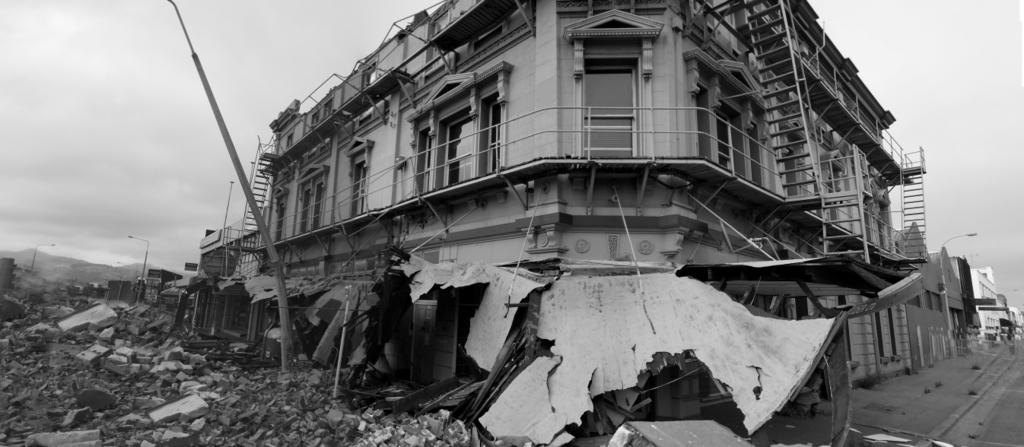What type of structure is present in the image? There is a building in the image. What can be seen attached to the building? There is a pole in the image. What materials are used to construct the building? Bricks and stones are visible in the image. What is visible in the background of the image? There is a sky visible in the background of the image. How many bedroom units are visible in the image? There is no reference to bedroom units in the image; it features a building, a pole, and materials used for construction. 